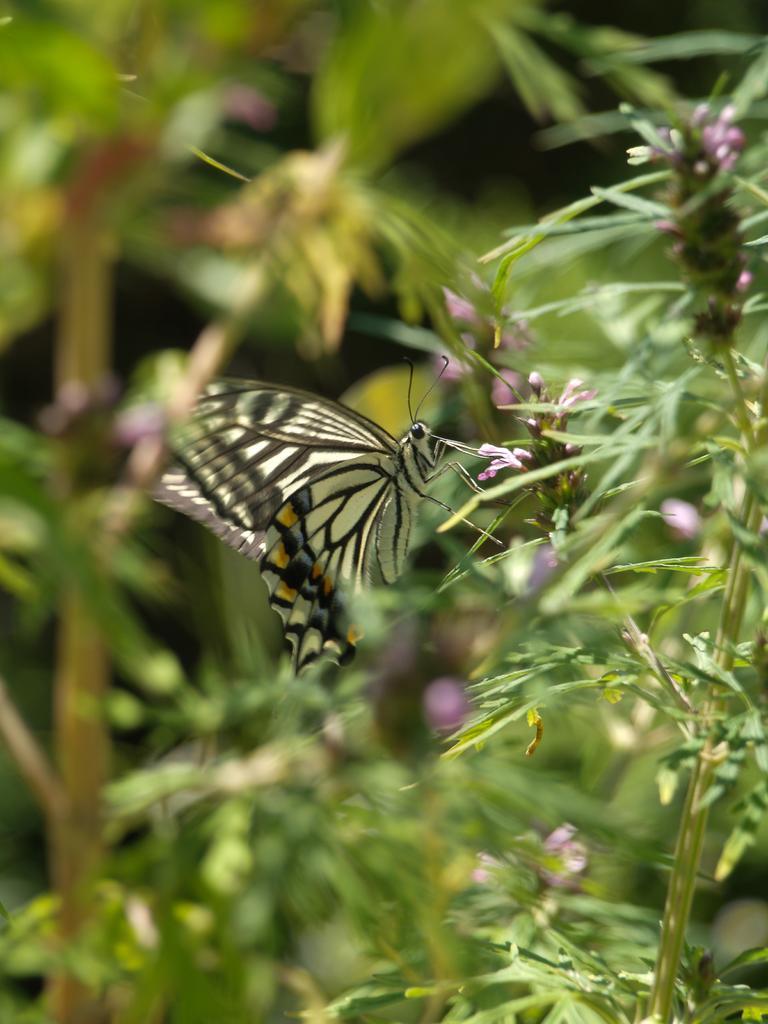Please provide a concise description of this image. In this image we can see few plants and a butterfly. 